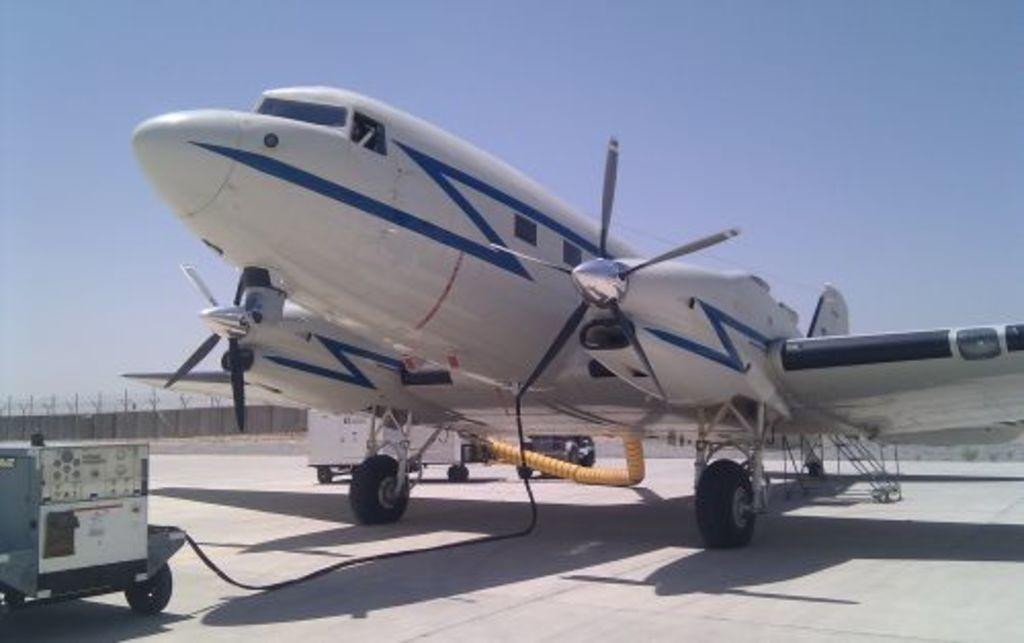What is the main subject of the image? The main subject of the image is an airplane. What else can be seen in the image besides the airplane? Vehicles are present on a path in the image. What can be seen in the background of the image? There is a wall, poles, a fence, and the sky visible in the background of the image. Can you tell me how many crackers are on the airplane in the image? There is no mention of crackers in the image; the focus is on the airplane, vehicles, and background elements. What type of quince is growing near the fence in the image? There is no quince present in the image; the background elements mentioned are a wall, poles, a fence, and the sky. 